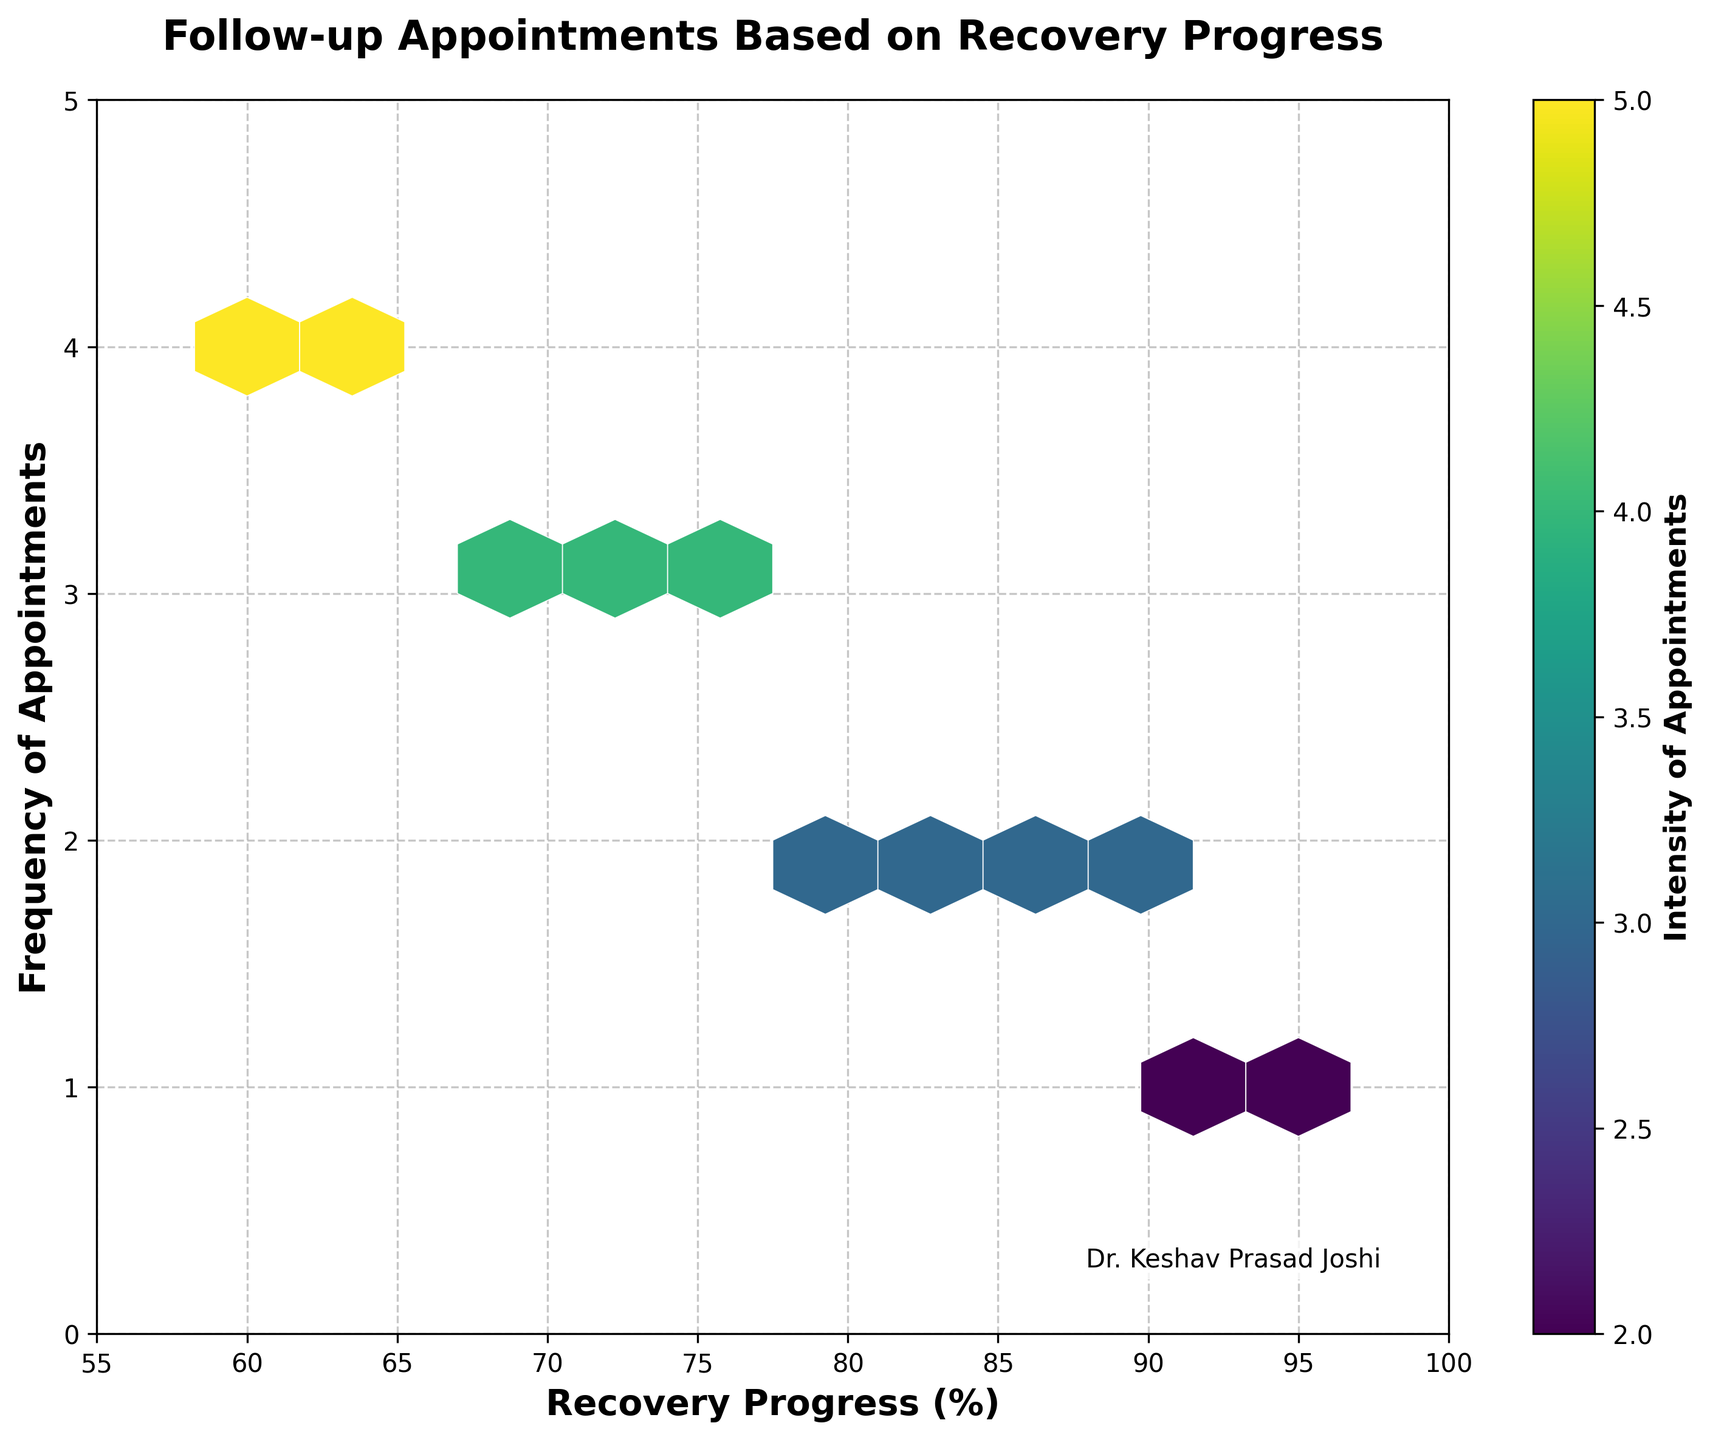What is the title of the plot? The title is usually found at the top of the plot and gives an overview of the displayed data. In this case, the title is "Follow-up Appointments Based on Recovery Progress".
Answer: Follow-up Appointments Based on Recovery Progress What are the x-axis and y-axis labels in the plot? The x-axis and y-axis labels help identify what the axes represent. Here, the x-axis label is "Recovery Progress (%)" and the y-axis label is "Frequency of Appointments".
Answer: Recovery Progress (%); Frequency of Appointments What does the color bar represent in this plot? The color bar is typically an indicator of the intensity or concentration of a particular variable. In this plot, it represents the "Intensity of Appointments".
Answer: Intensity of Appointments Which range of Recovery Progress (%) has the highest frequency of appointments? This can be determined by observing the most densely populated hexagonal cells along the x-axis. The densely populated cells appear around Recovery Progress of 60-70%.
Answer: 60-70% How does the intensity of appointments vary with recovery progress? By analyzing the color density in hexbin cells, we can determine the pattern. The hexbin cells with higher intensity (darker colors) indicate more intense appointments. As recovery progress decreases, the intensity of appointments increases.
Answer: Inversely proportional Are there any frequencies of appointments that are more common regardless of recovery progress? By looking at the y-axis, one can observe the distribution of data points. A frequency of 2 appointments appears to be the most common across various recovery percentages.
Answer: Frequency of 2 What role does Dr. Keshav Prasad Joshi play in this plot? A small text is placed at the bottom right of the plot, indicating that Dr. Keshav Prasad Joshi is likely responsible for the follow-up appointments and recovery progress data collection.
Answer: Data collection by Dr. Keshav Prasad Joshi Is there a frequency of appointments that coincides with both high and low recovery progress? By examining the entire y-axis range for different recovery percentages, one can see that a frequency of 2 appointments can be found both at high and low recovery progress percentages.
Answer: Yes, frequency of 2 